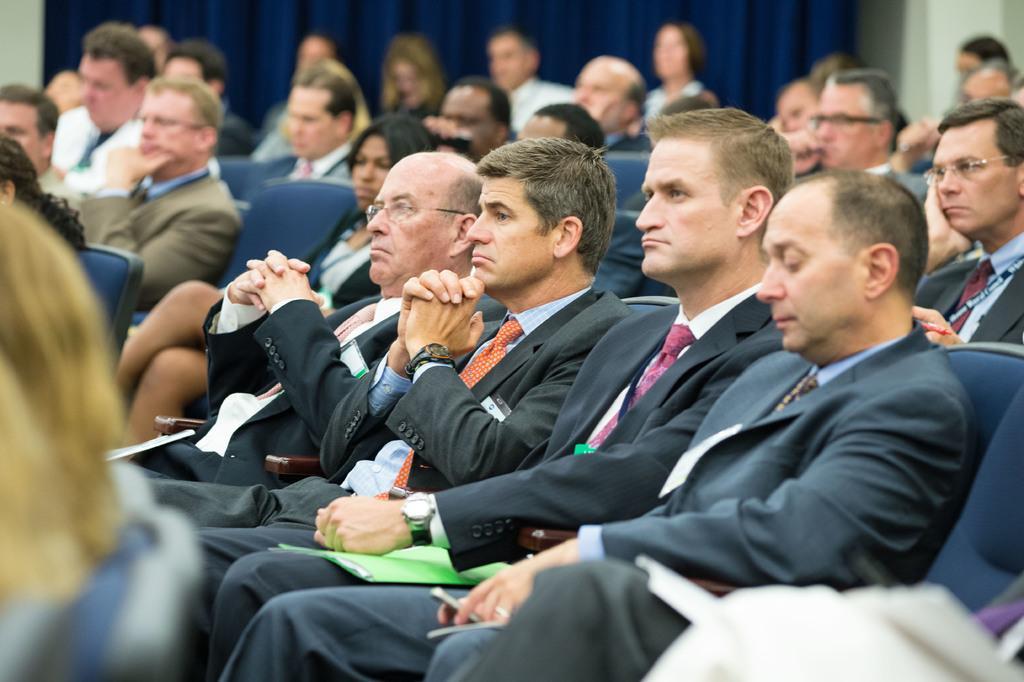Could you give a brief overview of what you see in this image? In this image I see number of people who are sitting on chairs and I see most of the men are wearing suits and in the background I see the blue color cloth over here. 